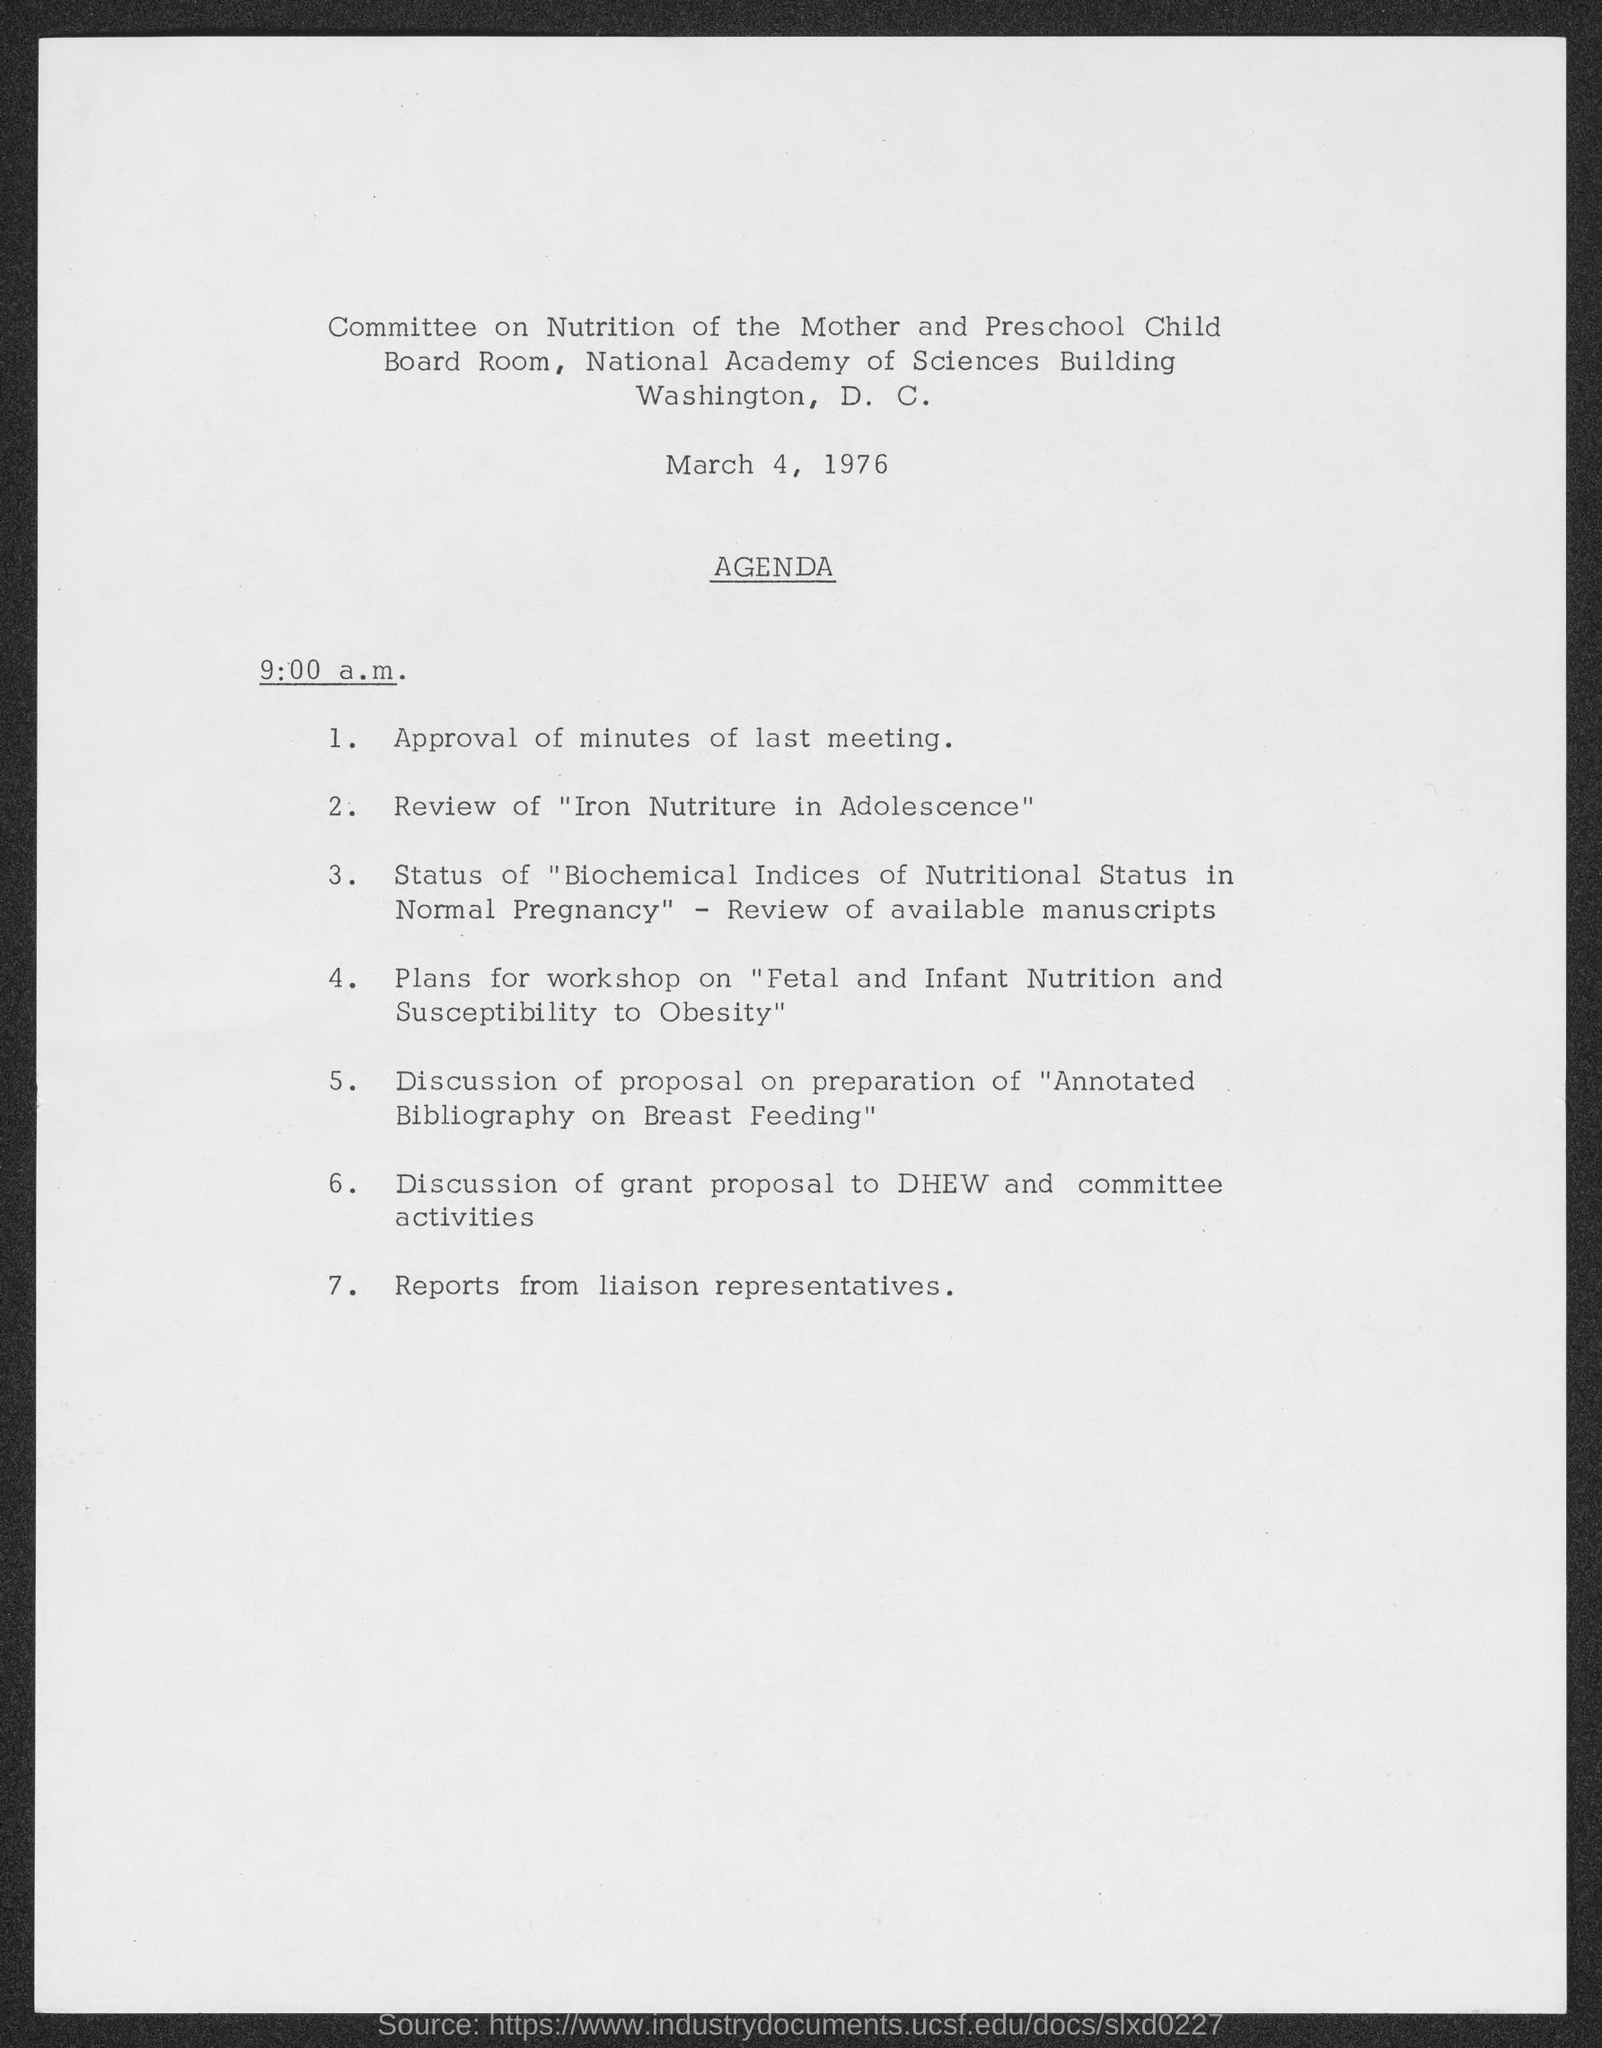What is the date mentioned in the document?
Make the answer very short. March 4, 1976. What is the time?
Your answer should be very brief. 9:00 a.m. 